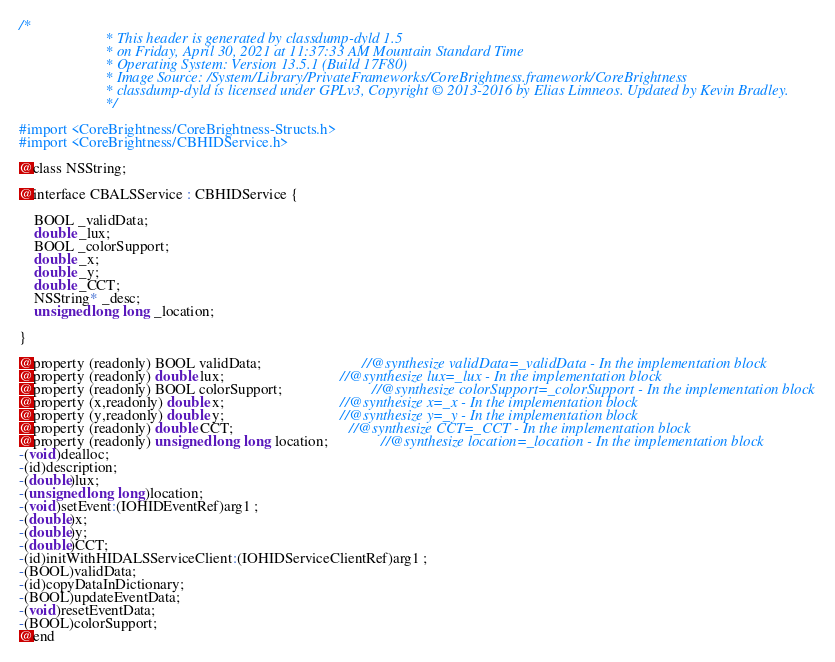<code> <loc_0><loc_0><loc_500><loc_500><_C_>/*
                       * This header is generated by classdump-dyld 1.5
                       * on Friday, April 30, 2021 at 11:37:33 AM Mountain Standard Time
                       * Operating System: Version 13.5.1 (Build 17F80)
                       * Image Source: /System/Library/PrivateFrameworks/CoreBrightness.framework/CoreBrightness
                       * classdump-dyld is licensed under GPLv3, Copyright © 2013-2016 by Elias Limneos. Updated by Kevin Bradley.
                       */

#import <CoreBrightness/CoreBrightness-Structs.h>
#import <CoreBrightness/CBHIDService.h>

@class NSString;

@interface CBALSService : CBHIDService {

	BOOL _validData;
	double _lux;
	BOOL _colorSupport;
	double _x;
	double _y;
	double _CCT;
	NSString* _desc;
	unsigned long long _location;

}

@property (readonly) BOOL validData;                           //@synthesize validData=_validData - In the implementation block
@property (readonly) double lux;                               //@synthesize lux=_lux - In the implementation block
@property (readonly) BOOL colorSupport;                        //@synthesize colorSupport=_colorSupport - In the implementation block
@property (x,readonly) double x;                               //@synthesize x=_x - In the implementation block
@property (y,readonly) double y;                               //@synthesize y=_y - In the implementation block
@property (readonly) double CCT;                               //@synthesize CCT=_CCT - In the implementation block
@property (readonly) unsigned long long location;              //@synthesize location=_location - In the implementation block
-(void)dealloc;
-(id)description;
-(double)lux;
-(unsigned long long)location;
-(void)setEvent:(IOHIDEventRef)arg1 ;
-(double)x;
-(double)y;
-(double)CCT;
-(id)initWithHIDALSServiceClient:(IOHIDServiceClientRef)arg1 ;
-(BOOL)validData;
-(id)copyDataInDictionary;
-(BOOL)updateEventData;
-(void)resetEventData;
-(BOOL)colorSupport;
@end

</code> 